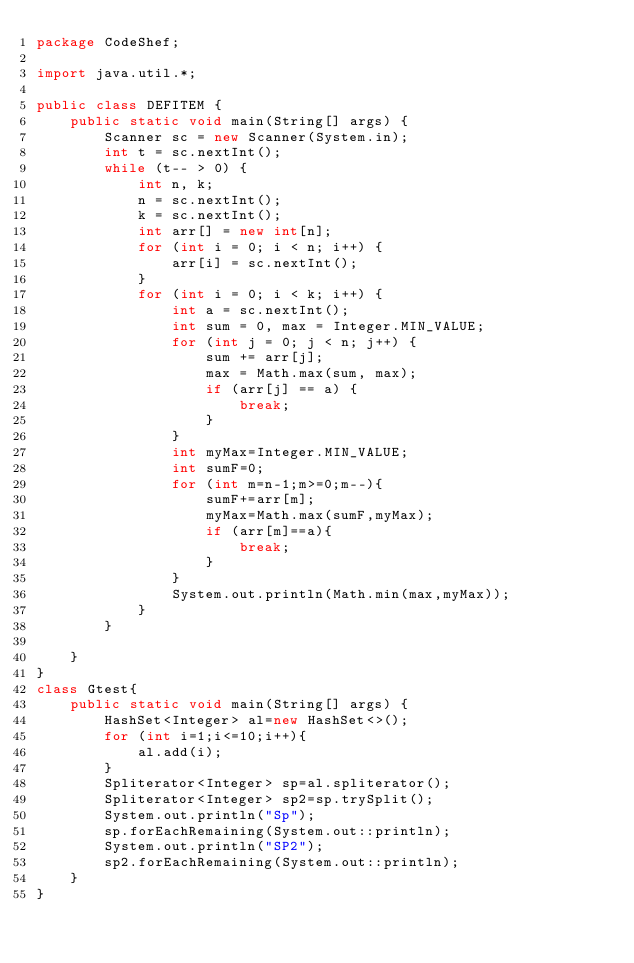<code> <loc_0><loc_0><loc_500><loc_500><_Java_>package CodeShef;

import java.util.*;

public class DEFITEM {
    public static void main(String[] args) {
        Scanner sc = new Scanner(System.in);
        int t = sc.nextInt();
        while (t-- > 0) {
            int n, k;
            n = sc.nextInt();
            k = sc.nextInt();
            int arr[] = new int[n];
            for (int i = 0; i < n; i++) {
                arr[i] = sc.nextInt();
            }
            for (int i = 0; i < k; i++) {
                int a = sc.nextInt();
                int sum = 0, max = Integer.MIN_VALUE;
                for (int j = 0; j < n; j++) {
                    sum += arr[j];
                    max = Math.max(sum, max);
                    if (arr[j] == a) {
                        break;
                    }
                }
                int myMax=Integer.MIN_VALUE;
                int sumF=0;
                for (int m=n-1;m>=0;m--){
                    sumF+=arr[m];
                    myMax=Math.max(sumF,myMax);
                    if (arr[m]==a){
                        break;
                    }
                }
                System.out.println(Math.min(max,myMax));
            }
        }

    }
}
class Gtest{
    public static void main(String[] args) {
        HashSet<Integer> al=new HashSet<>();
        for (int i=1;i<=10;i++){
            al.add(i);
        }
        Spliterator<Integer> sp=al.spliterator();
        Spliterator<Integer> sp2=sp.trySplit();
        System.out.println("Sp");
        sp.forEachRemaining(System.out::println);
        System.out.println("SP2");
        sp2.forEachRemaining(System.out::println);
    }
}</code> 